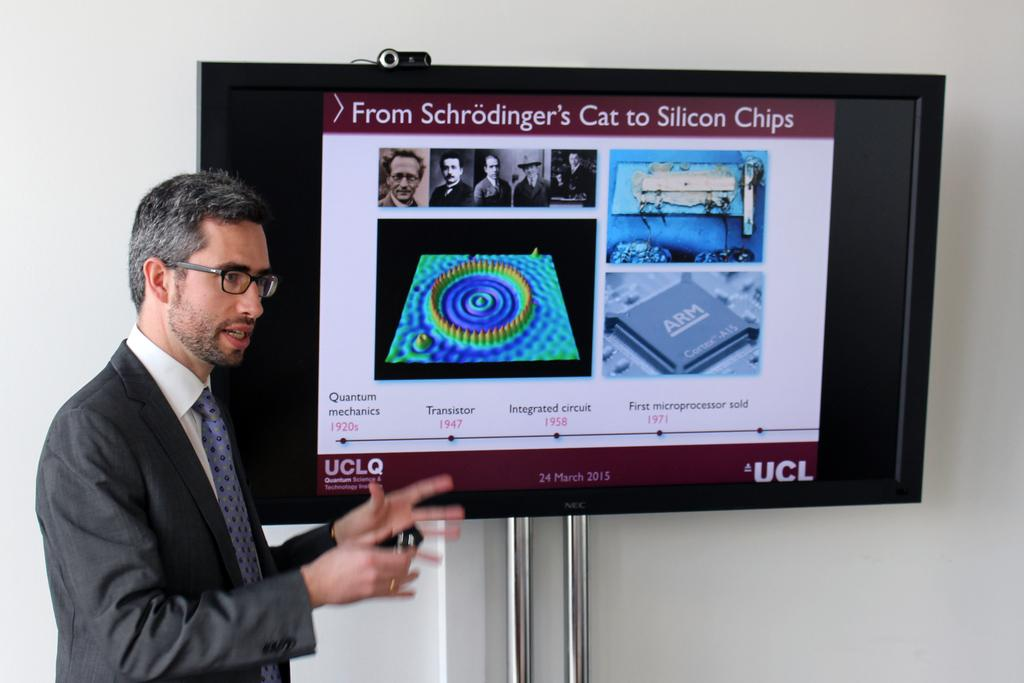What is the man in the image wearing? The man is wearing a suit and a tie. What is the man doing in the image? The man is standing in the image. What is on the TV screen in the image? There is a poster on the TV screen. What color is the wall in the background of the image? The wall is white in color. What type of underwear is the man wearing in the image? There is no information about the man's underwear in the image, so we cannot determine what type he is wearing. 